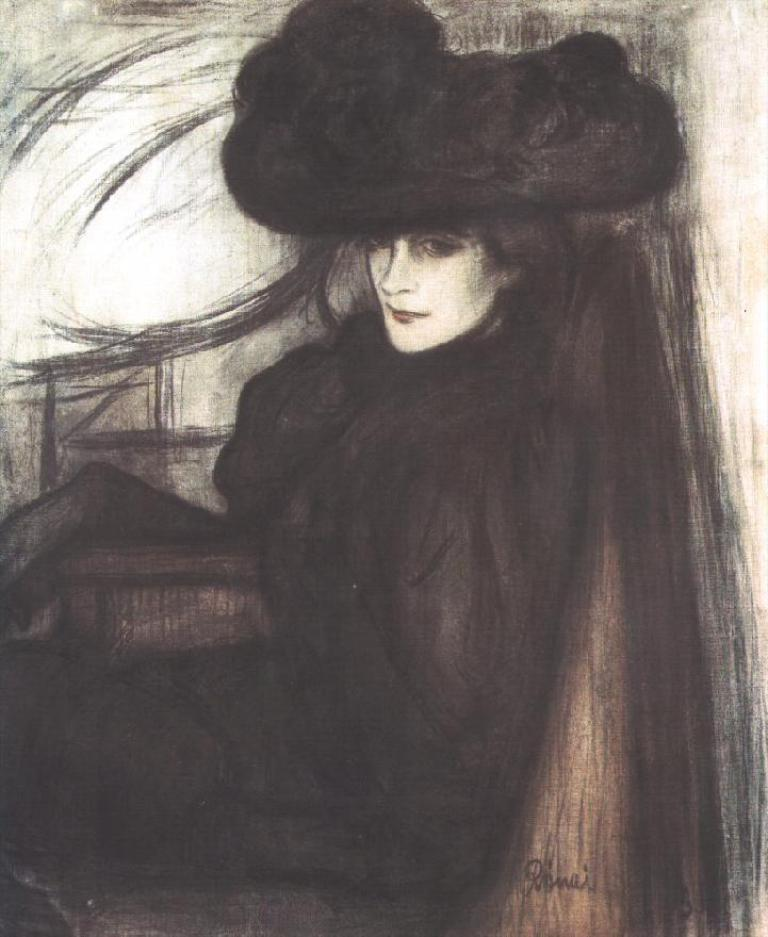What is the main subject of the image? There is a painting in the image. What is the painting depicting? The painting depicts a woman. How is the woman portrayed in the painting? The woman is portrayed in black color. Reasoning: Let's think step by breaking down the conversation step by step. We start by identifying the main subject of the image, which is the painting. Then, we describe the content of the painting, mentioning that it depicts a woman. Finally, we provide details about the woman's appearance in the painting, stating that she is portrayed in black color. Absurd Question/Answer: Can you tell me how many zebras are present in the painting? There are no zebras depicted in the painting; it features a woman portrayed in black color. What type of club is the woman holding in the painting? There is no club present in the painting; it only depicts a woman portrayed in black color. What type of work is the woman doing in the painting? There is no indication of the woman performing any work in the painting; she is simply portrayed in black color. 